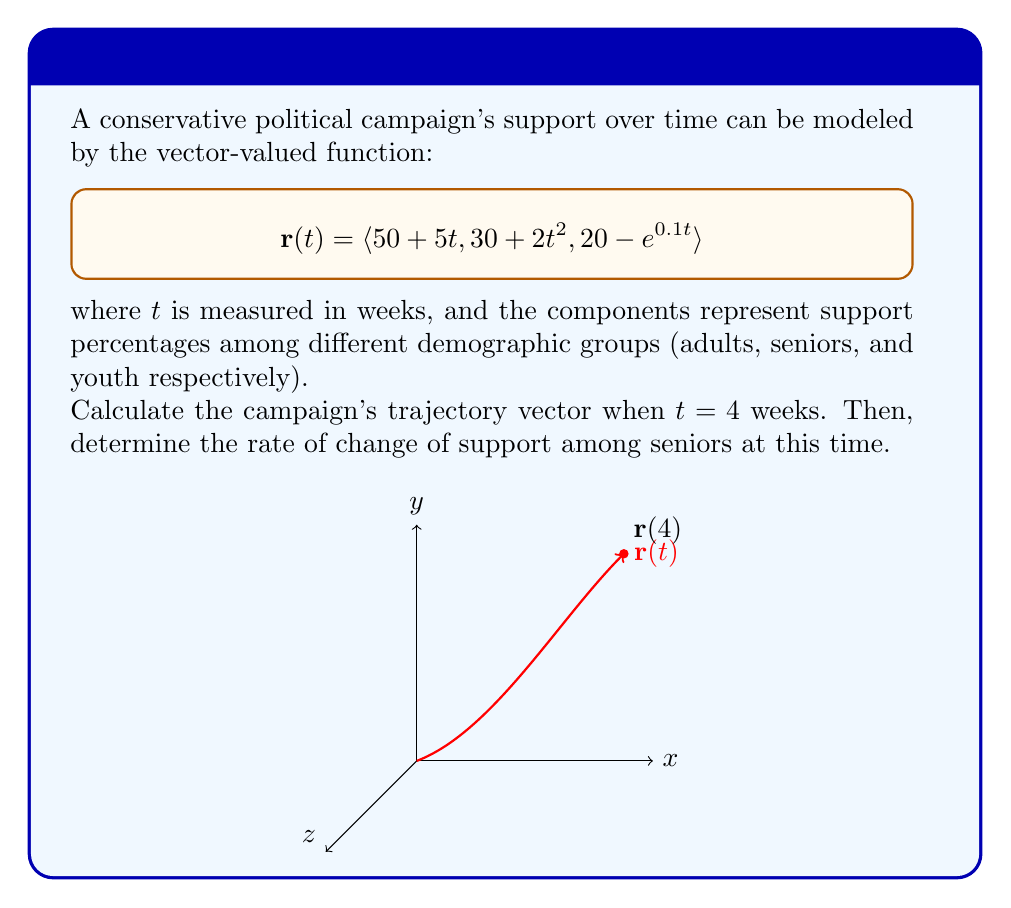What is the answer to this math problem? Let's approach this step-by-step:

1) The trajectory vector at $t = 4$ weeks is found by evaluating $\mathbf{r}(4)$:

   $$\mathbf{r}(4) = \langle 50 + 5(4), 30 + 2(4)^2, 20 - e^{0.1(4)} \rangle$$

2) Simplify:
   $$\mathbf{r}(4) = \langle 70, 62, 20 - e^{0.4} \rangle$$

3) Calculate $e^{0.4} \approx 1.4918$:
   $$\mathbf{r}(4) \approx \langle 70, 62, 18.51 \rangle$$

4) To find the rate of change of support among seniors at $t = 4$, we need to calculate the derivative of the second component of $\mathbf{r}(t)$ and evaluate it at $t = 4$:

   $$\frac{d}{dt}(30 + 2t^2) = 4t$$

5) Evaluate at $t = 4$:
   $$4(4) = 16$$

Therefore, the rate of change of support among seniors at $t = 4$ weeks is 16 percentage points per week.
Answer: $\mathbf{r}(4) \approx \langle 70, 62, 18.51 \rangle$; Rate of change among seniors: 16 percentage points/week 